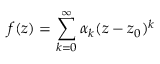<formula> <loc_0><loc_0><loc_500><loc_500>f ( z ) = \sum _ { k = 0 } ^ { \infty } \alpha _ { k } ( z - z _ { 0 } ) ^ { k }</formula> 